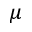<formula> <loc_0><loc_0><loc_500><loc_500>\mu</formula> 